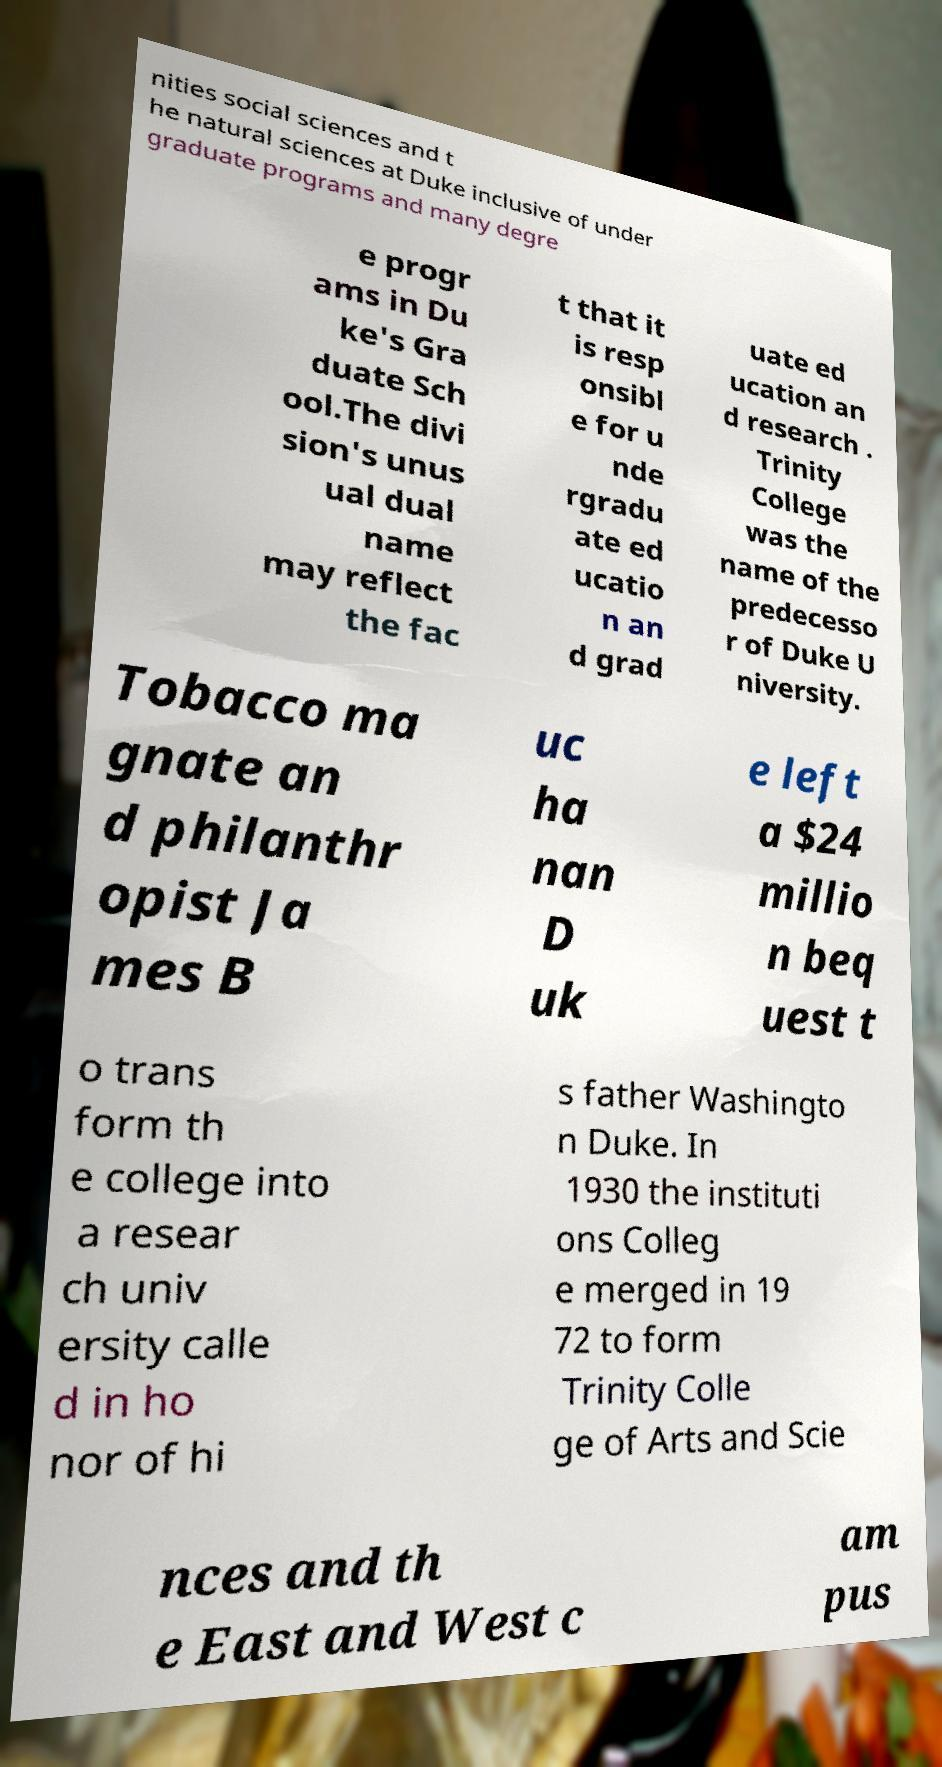Can you accurately transcribe the text from the provided image for me? nities social sciences and t he natural sciences at Duke inclusive of under graduate programs and many degre e progr ams in Du ke's Gra duate Sch ool.The divi sion's unus ual dual name may reflect the fac t that it is resp onsibl e for u nde rgradu ate ed ucatio n an d grad uate ed ucation an d research . Trinity College was the name of the predecesso r of Duke U niversity. Tobacco ma gnate an d philanthr opist Ja mes B uc ha nan D uk e left a $24 millio n beq uest t o trans form th e college into a resear ch univ ersity calle d in ho nor of hi s father Washingto n Duke. In 1930 the instituti ons Colleg e merged in 19 72 to form Trinity Colle ge of Arts and Scie nces and th e East and West c am pus 